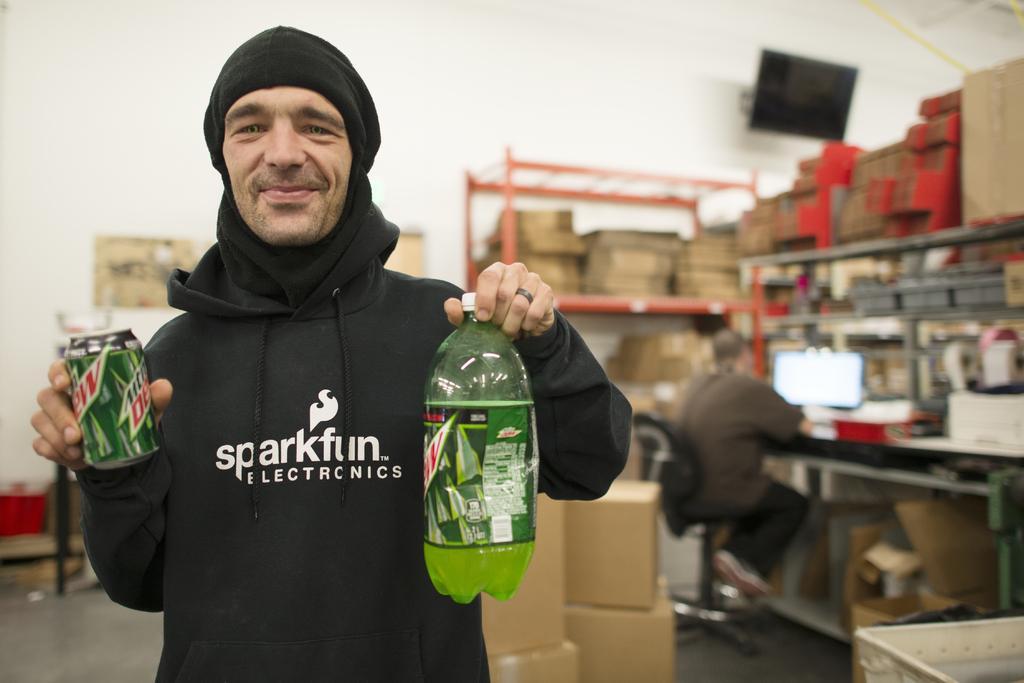Could you give a brief overview of what you see in this image? Front this person is holding bottle and tin. Far there are racks and filled with cardboard. This man is sitting on a chair and working in-front of monitor. 